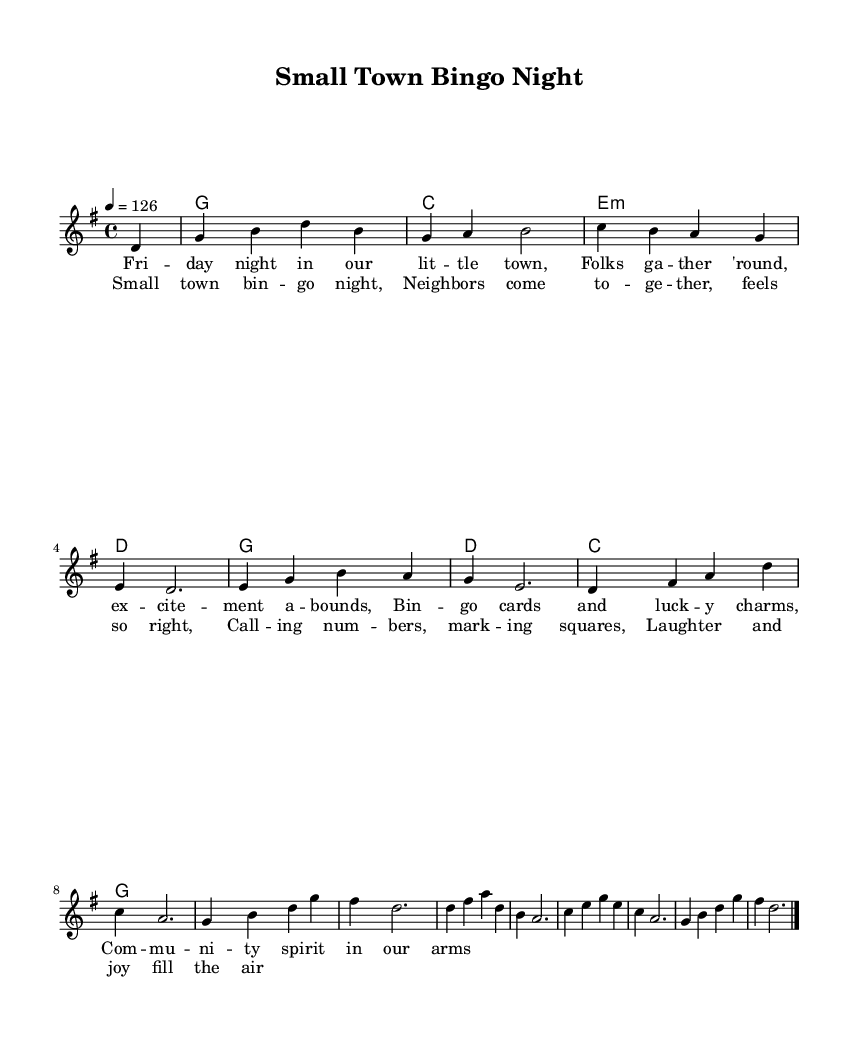What is the key signature of this music? The key signature is G major, which has one sharp (F#). This is indicated at the beginning of the sheet music before the staff.
Answer: G major What is the time signature of this piece? The time signature is 4/4, meaning there are four beats in each measure and the quarter note receives one beat. This is found at the beginning of the score.
Answer: 4/4 What is the tempo marking for this piece? The tempo marking is 126 beats per minute, indicated by the "4 = 126" notation, which specifies the speed of the music.
Answer: 126 What is the first lyric of the song? The first lyric of the song is "Friday night in our little town," found at the beginning of the lyrics section corresponding to the melody.
Answer: Friday night in our little town What community theme is highlighted in the chorus? The chorus emphasizes togetherness and joy within the neighborhood, as evidenced by phrases like "Neighbors come together" and "Laughter and joy fill the air." This reflects community spirit.
Answer: Togetherness What is the main event taking place in the lyrics? The main event taking place in the lyrics is a bingo night, as indicated by phrases like "Bingo cards" and "Calling numbers," which describe the activity central to the community gathering.
Answer: Bingo night 